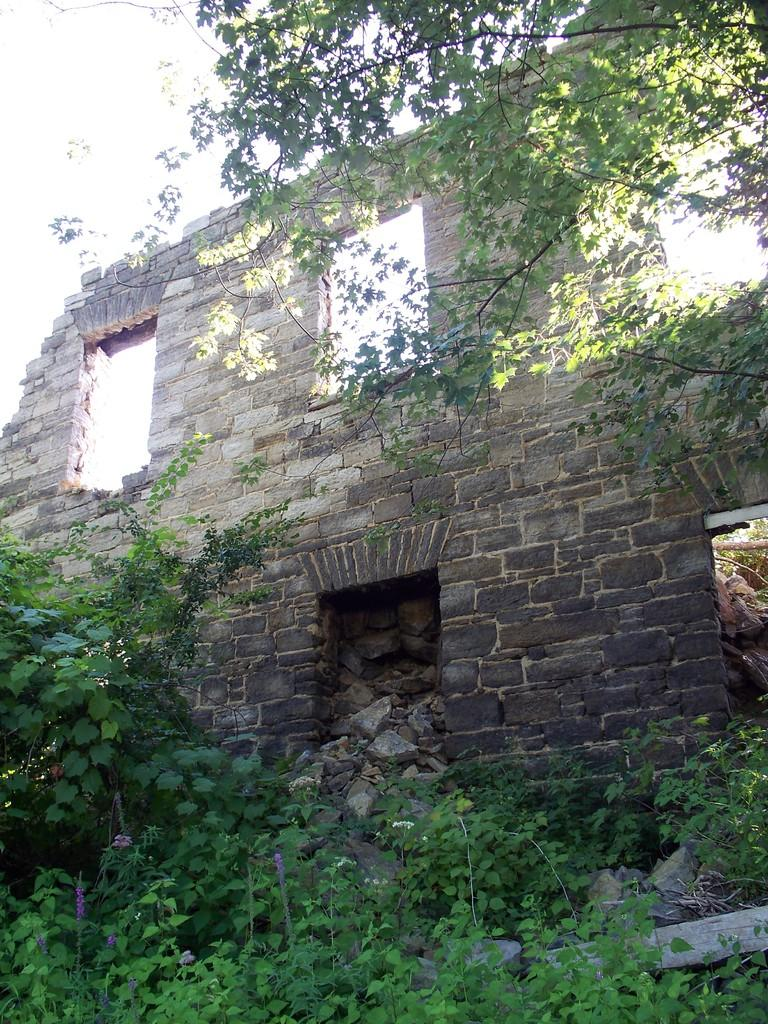What type of material is used for the wall in the image? The wall in the image is made of granite stones. What natural element is present in the image? There is a tree in the image. What type of vegetation can be seen in the image? There are plants in the image. What type of oatmeal is being prepared in the image? There is no oatmeal present in the image; it features a wall with granite stones, a tree, and plants. 